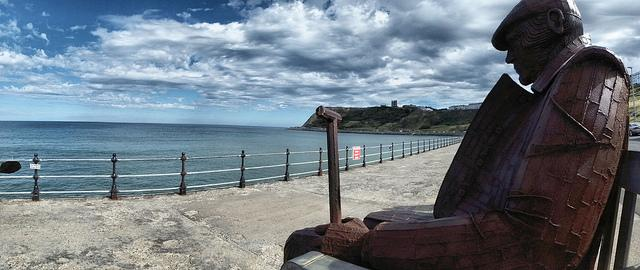What is this man doing?

Choices:
A) is resting
B) is surfing
C) watching movie
D) driving bike is resting 